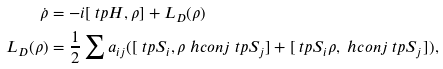Convert formula to latex. <formula><loc_0><loc_0><loc_500><loc_500>\dot { \rho } & = - i [ \ t p { H } , \rho ] + L _ { D } ( \rho ) \\ L _ { D } ( \rho ) & = \frac { 1 } { 2 } \sum a _ { i j } ( [ \ t p { S } _ { i } , \rho \ h c o n j { \ t p { S } _ { j } } ] + [ \ t p { S } _ { i } \rho , \ h c o n j { \ t p { S } _ { j } } ] ) ,</formula> 